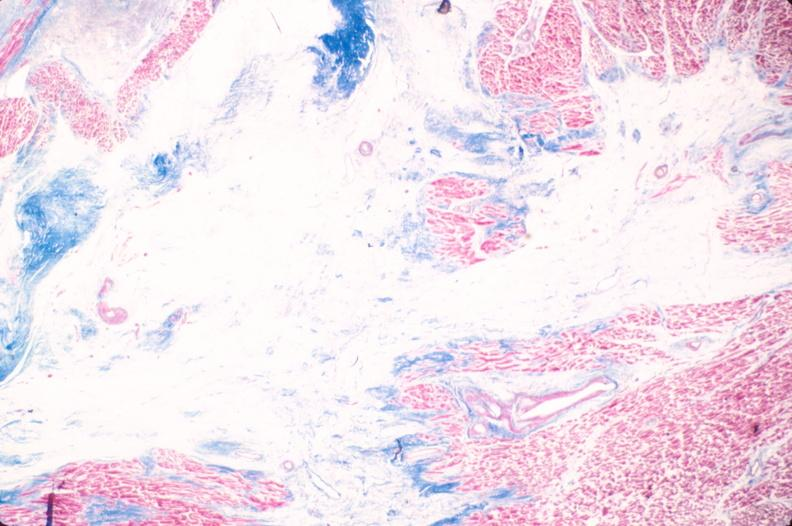does this image show heart, old myocardial infarction with fibrosis, trichrome?
Answer the question using a single word or phrase. Yes 